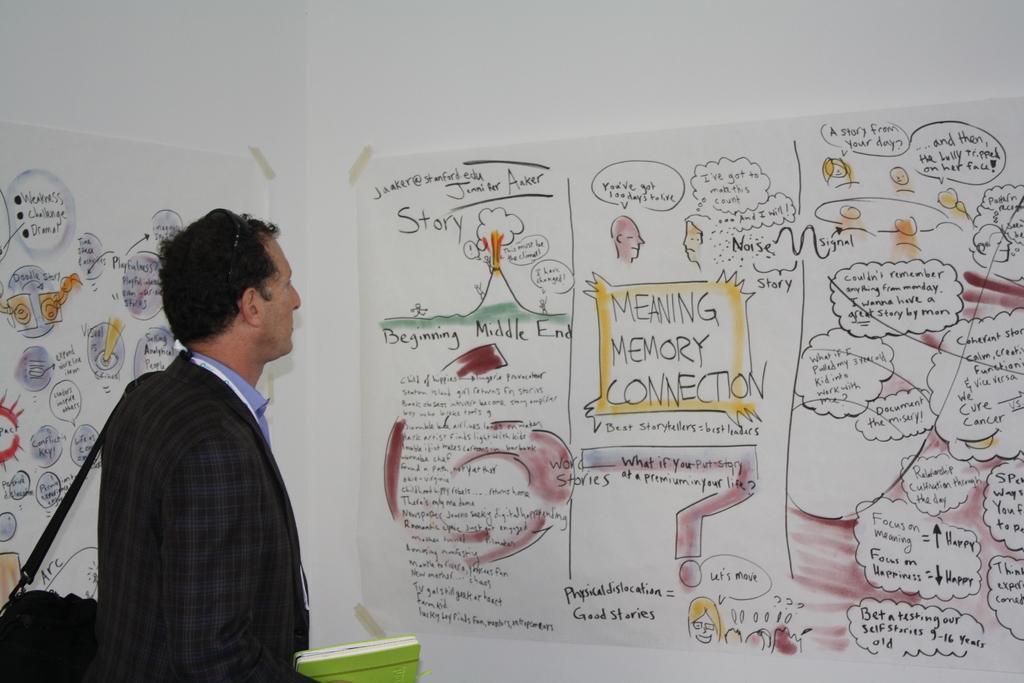<image>
Share a concise interpretation of the image provided. A man is looking at a poster with the headline "Meaning Memory Connection"which is in a yellow box. 